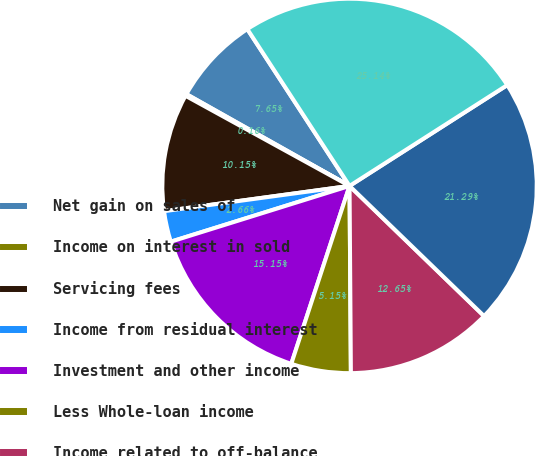<chart> <loc_0><loc_0><loc_500><loc_500><pie_chart><fcel>Net gain on sales of<fcel>Income on interest in sold<fcel>Servicing fees<fcel>Income from residual interest<fcel>Investment and other income<fcel>Less Whole-loan income<fcel>Income related to off-balance<fcel>Finance receivables sold<fcel>Servicing portfolio as of<nl><fcel>7.65%<fcel>0.16%<fcel>10.15%<fcel>2.66%<fcel>15.15%<fcel>5.15%<fcel>12.65%<fcel>21.29%<fcel>25.14%<nl></chart> 